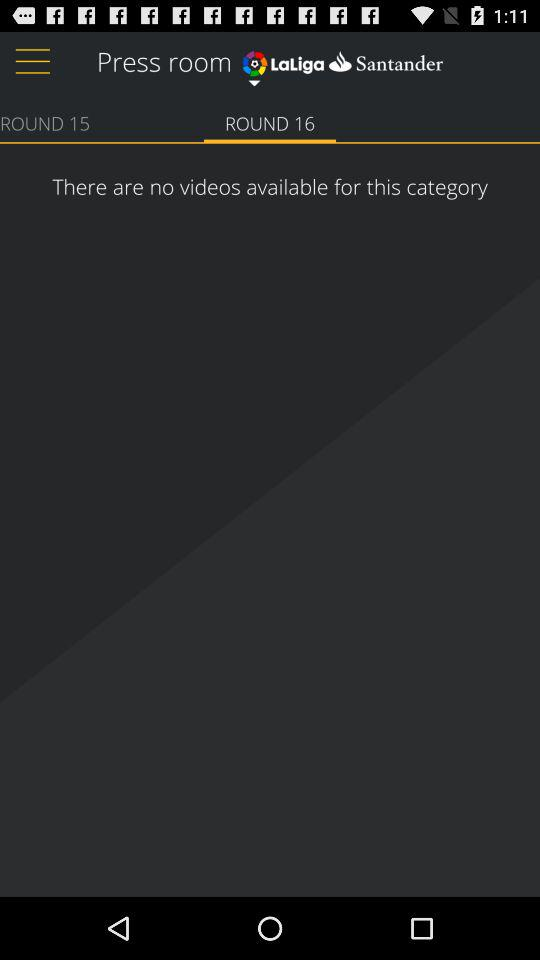Which tab is selected? The selected tab is "ROUND 16". 